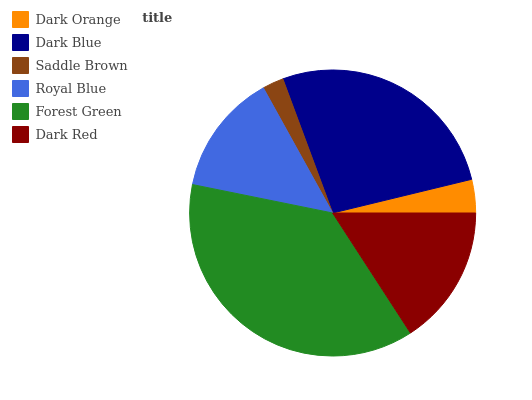Is Saddle Brown the minimum?
Answer yes or no. Yes. Is Forest Green the maximum?
Answer yes or no. Yes. Is Dark Blue the minimum?
Answer yes or no. No. Is Dark Blue the maximum?
Answer yes or no. No. Is Dark Blue greater than Dark Orange?
Answer yes or no. Yes. Is Dark Orange less than Dark Blue?
Answer yes or no. Yes. Is Dark Orange greater than Dark Blue?
Answer yes or no. No. Is Dark Blue less than Dark Orange?
Answer yes or no. No. Is Dark Red the high median?
Answer yes or no. Yes. Is Royal Blue the low median?
Answer yes or no. Yes. Is Dark Blue the high median?
Answer yes or no. No. Is Forest Green the low median?
Answer yes or no. No. 